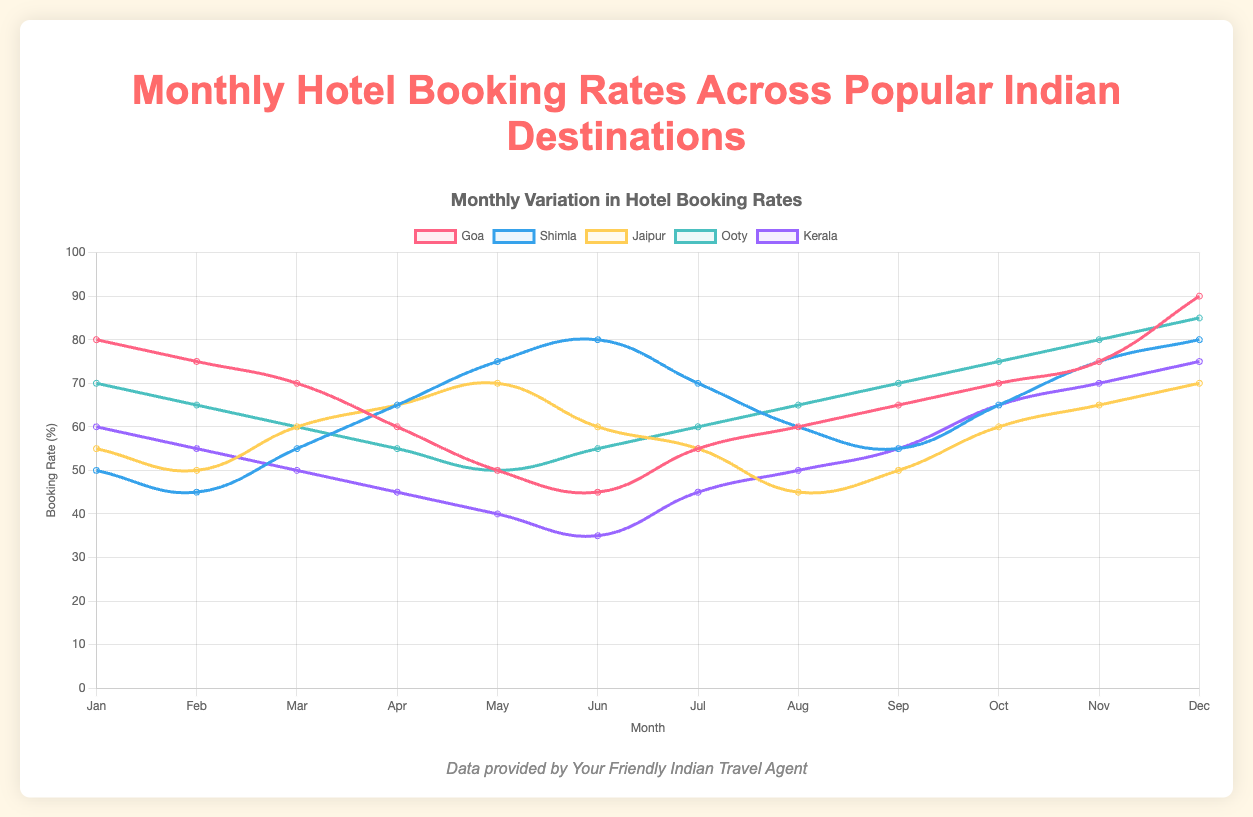Which destination has the highest hotel booking rate in December? The data shows that Goa has the highest rate in December with a rate of 90.
Answer: Goa Which month shows the lowest hotel booking rate for Kerala? By looking at the line plot for Kerala, the lowest rate is in June at 35.
Answer: June Compare the booking rates between Shimla and Jaipur in July. Which one is higher? Shimla has a rate of 70 in July, while Jaipur has a rate of 55. Thus, Shimla has a higher rate.
Answer: Shimla What is the average hotel booking rate for Ooty from May to August? Calculate the average by summing the rates for May (50), June (55), July (60), and August (65), then divide by 4: (50+55+60+65)/4 = 57.5.
Answer: 57.5 Which destination has the most consistent (least fluctuating) rates throughout the year? By looking at the plots, Jaipur has the least fluctuation with rates ranging from 45 to 70, compared to other destinations.
Answer: Jaipur What is the total increase in the booking rate for Goa from June to December? The rate in June is 45 and in December is 90, so the total increase is 90 - 45 = 45.
Answer: 45 How do the booking rates in January compare among all destinations, and which is the highest? The rates in January are Goa (80), Shimla (50), Jaipur (55), Ooty (70), and Kerala (60). Goa has the highest rate.
Answer: Goa Which month do Shimla and Ooty have the same booking rate and what is it? Both Shimla and Ooty have the same booking rate in June at 80.
Answer: June, 80 If you take an average of the booking rates for Jaipur for the first half of the year (January to June), what is it? Summing the rates for the first half months: (55+50+60+65+70+60), the total is 360. Divide by 6 months: 360/6 = 60.
Answer: 60 Between March and April, which destination shows the greatest rate increase? Shimla shows an increase from 55 to 65, giving an increase of 10, the highest in comparison to other destinations.
Answer: Shimla 